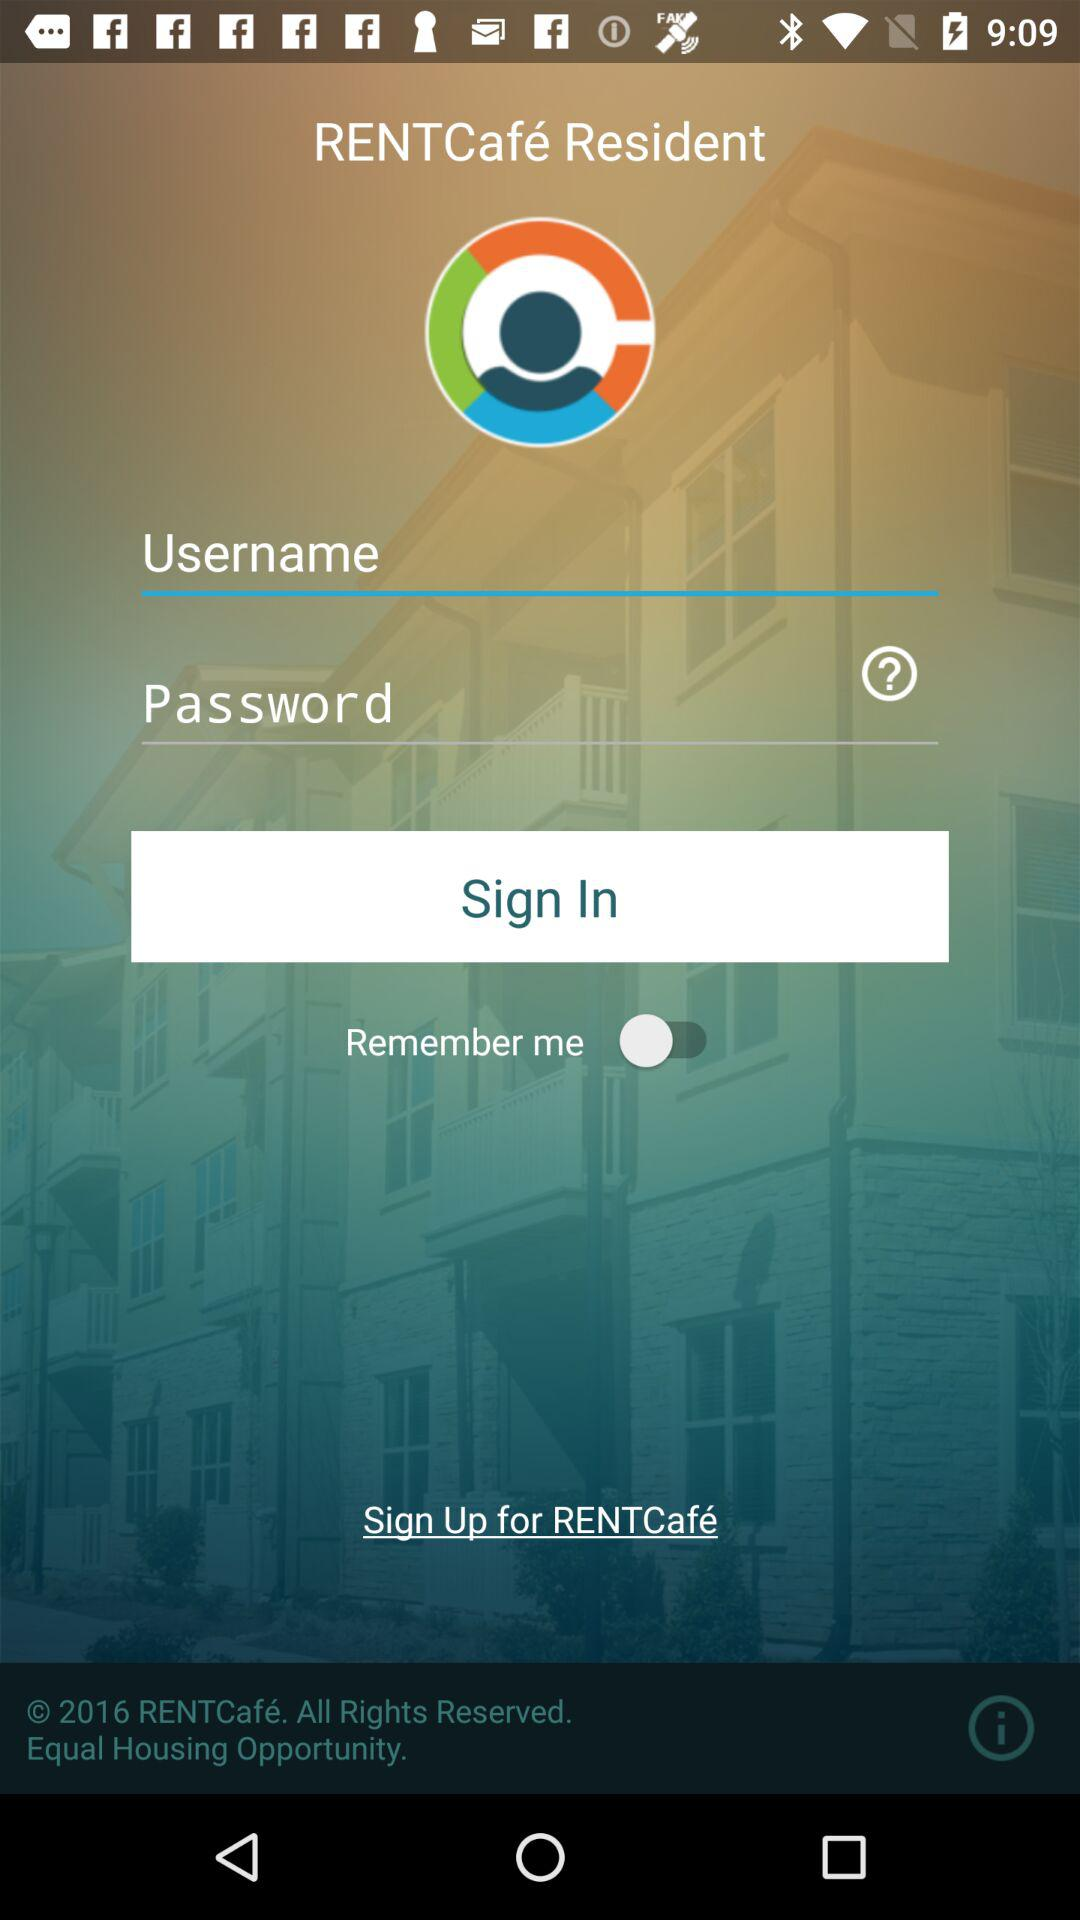What is the status of "Remember me"? The status is "off". 